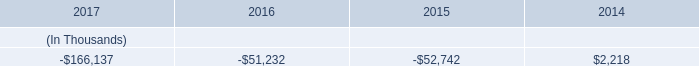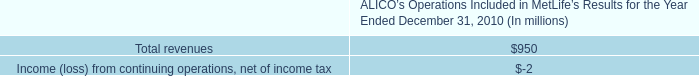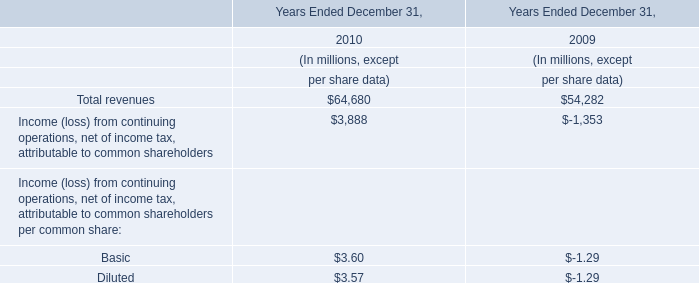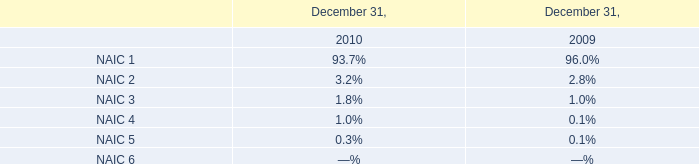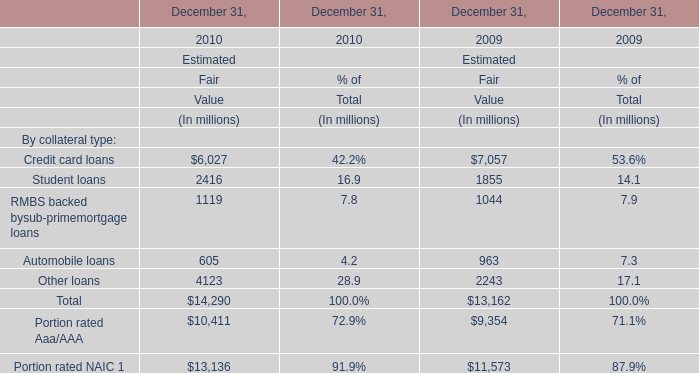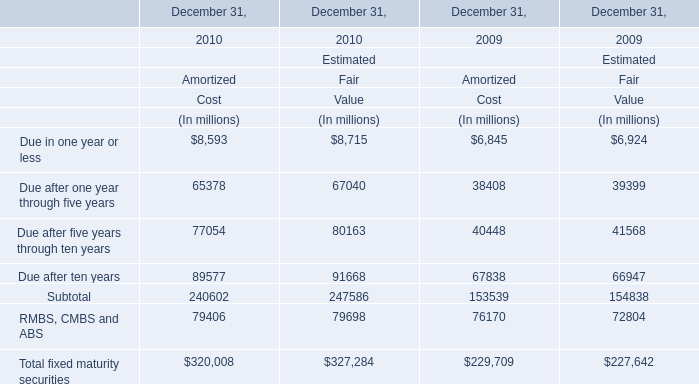What do all elements for Amortized sum up without those elements smaller than 60000, in 2010? (in million) 
Computations: (((65378 + 77054) + 89577) + 79406)
Answer: 311415.0. 